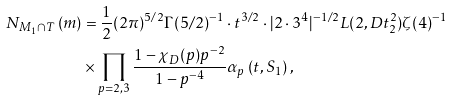<formula> <loc_0><loc_0><loc_500><loc_500>N _ { M _ { 1 } \cap T } \left ( m \right ) & = \frac { 1 } { 2 } ( 2 \pi ) ^ { 5 / 2 } \Gamma ( 5 / 2 ) ^ { - 1 } \cdot t ^ { 3 / 2 } \cdot | 2 \cdot 3 ^ { 4 } | ^ { - 1 / 2 } L ( 2 , D t _ { 2 } ^ { 2 } ) \zeta ( 4 ) ^ { - 1 } \\ & \times \prod _ { p = 2 , 3 } \frac { 1 - \chi _ { D } ( p ) p ^ { - 2 } } { 1 - p ^ { - 4 } } \alpha _ { p } \left ( t , S _ { 1 } \right ) ,</formula> 